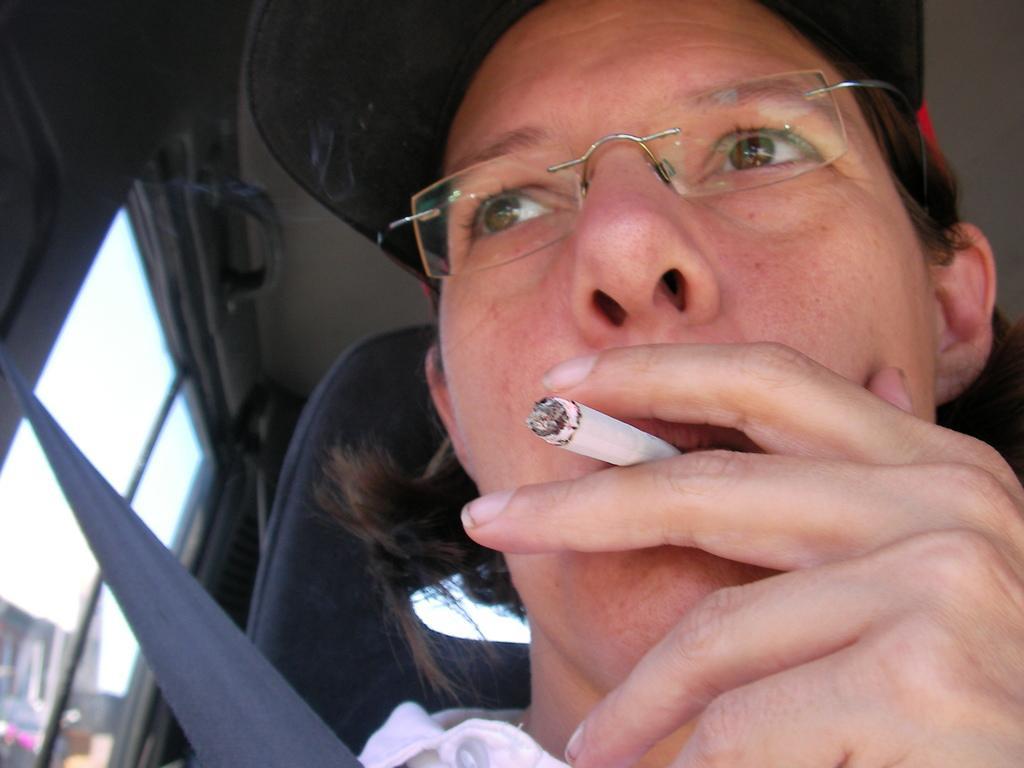Describe this image in one or two sentences. This picture shows a man seated in the vehicle and he wore spectacles on his face and he wore a cap on his head and he is smoking a cigarette by holding in the hand. 